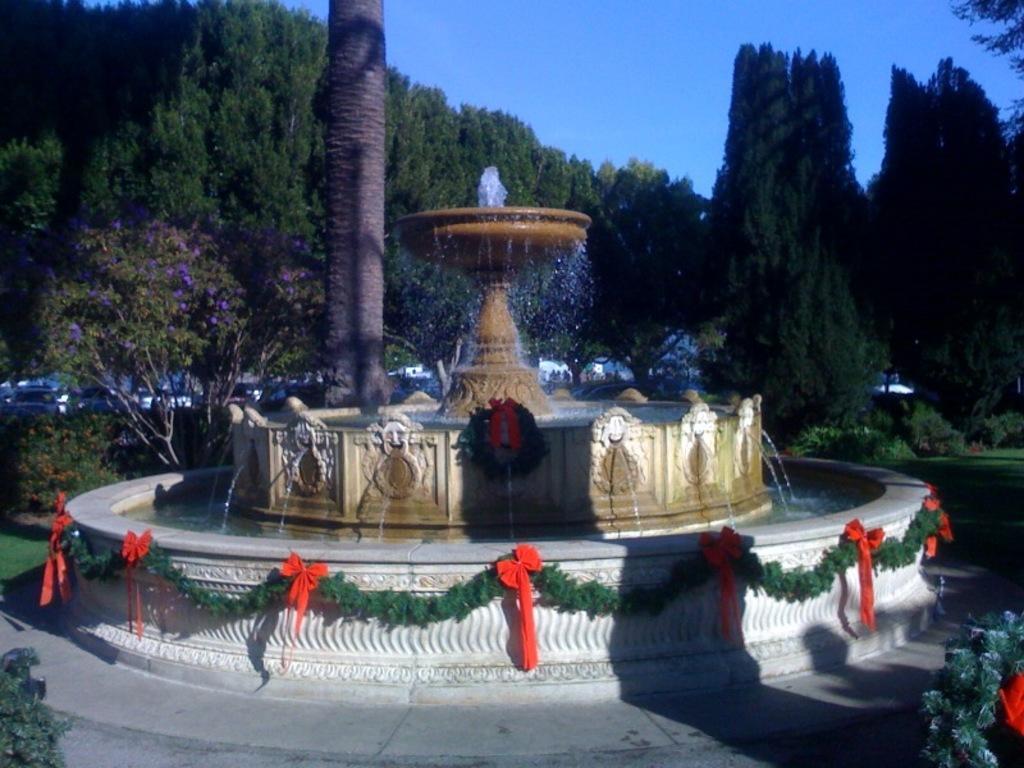How would you summarize this image in a sentence or two? There is a beautiful water fountain and around the fountain there is a tall tree and many other trees and in the background there is a sky. 